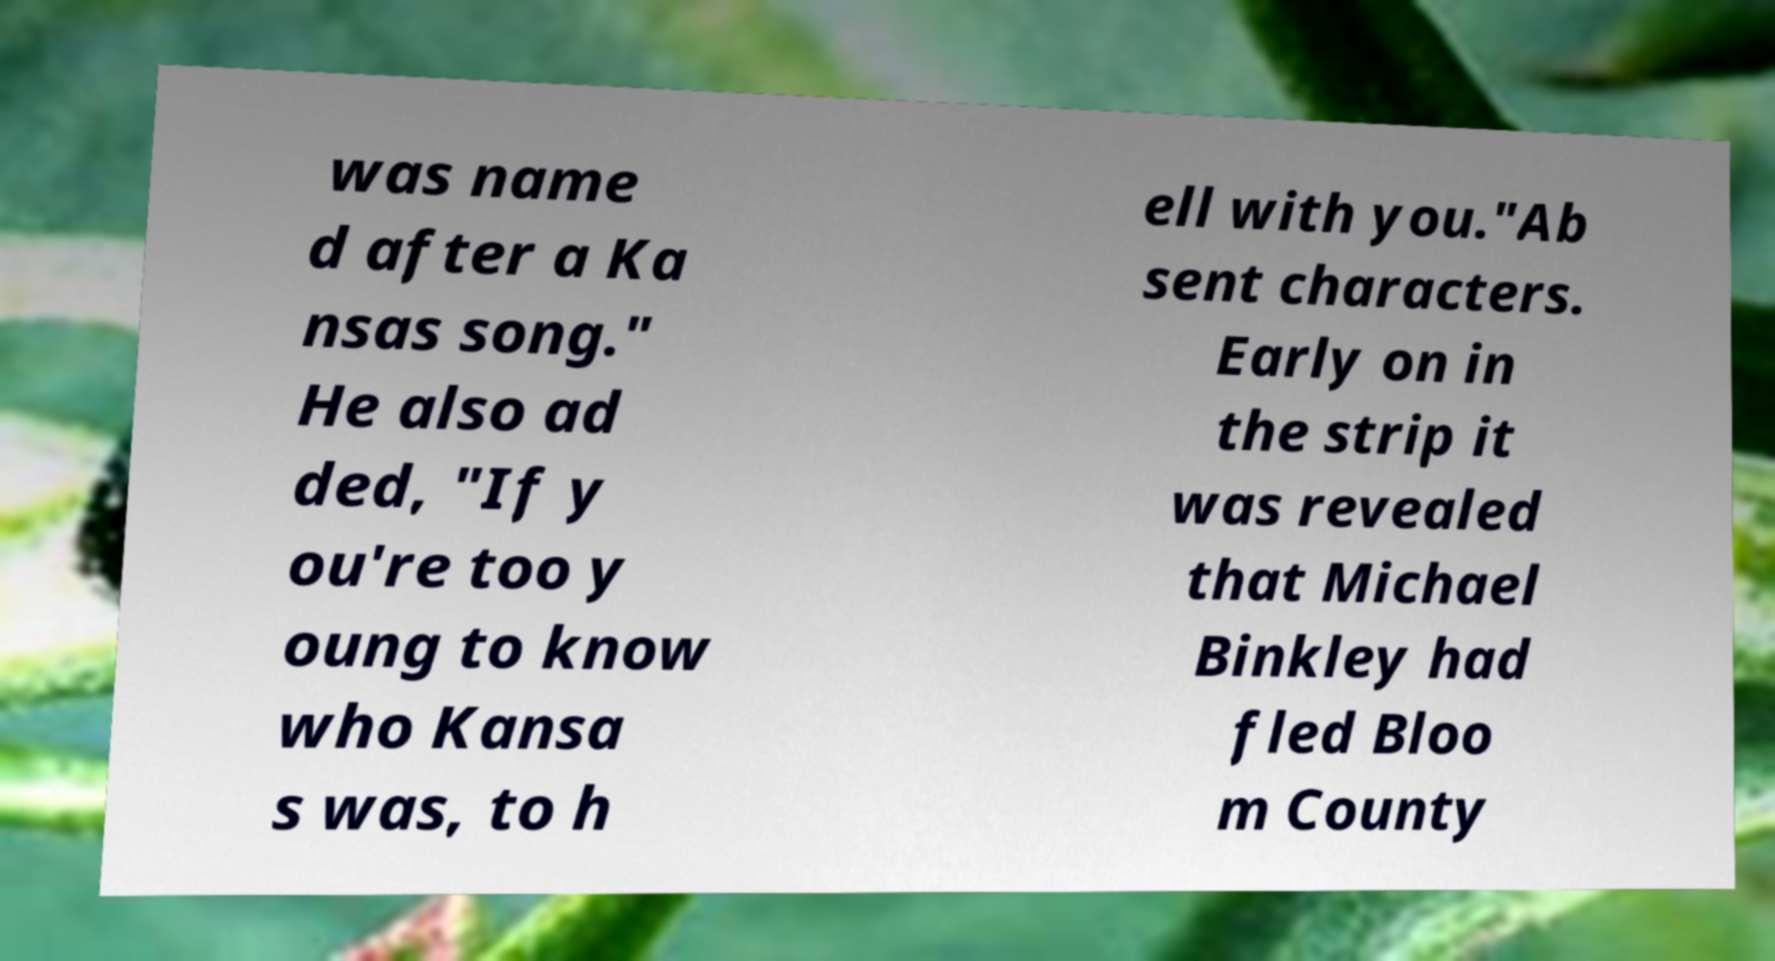For documentation purposes, I need the text within this image transcribed. Could you provide that? was name d after a Ka nsas song." He also ad ded, "If y ou're too y oung to know who Kansa s was, to h ell with you."Ab sent characters. Early on in the strip it was revealed that Michael Binkley had fled Bloo m County 